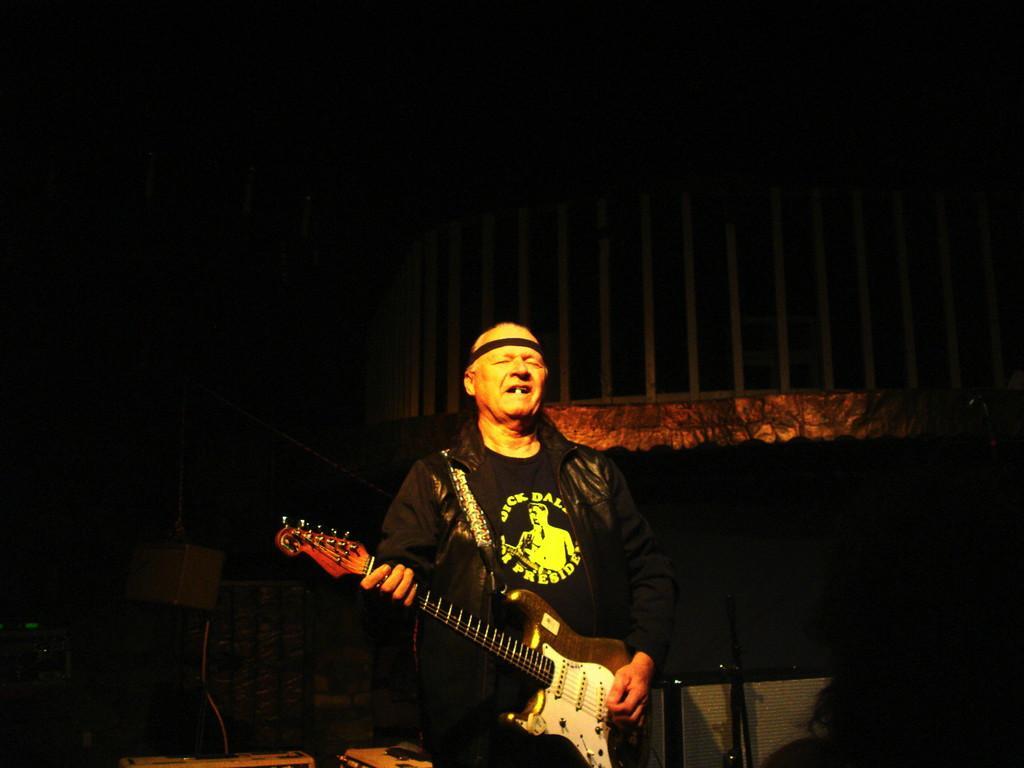Describe this image in one or two sentences. In this image, we can see a person standing and holding a guitar. There is a dark background. 